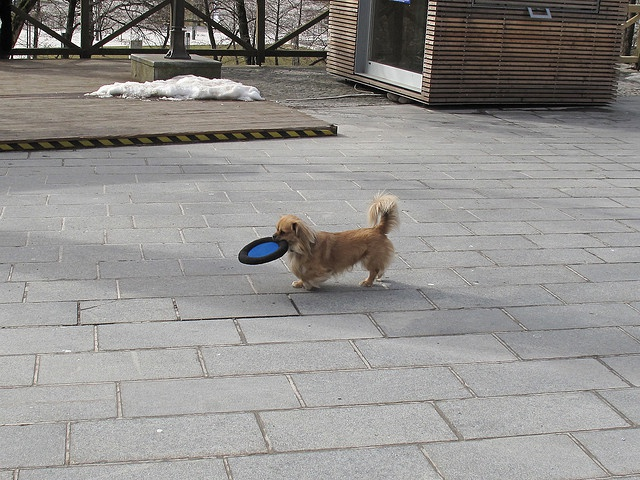Describe the objects in this image and their specific colors. I can see dog in black, maroon, and gray tones and frisbee in black, blue, and navy tones in this image. 